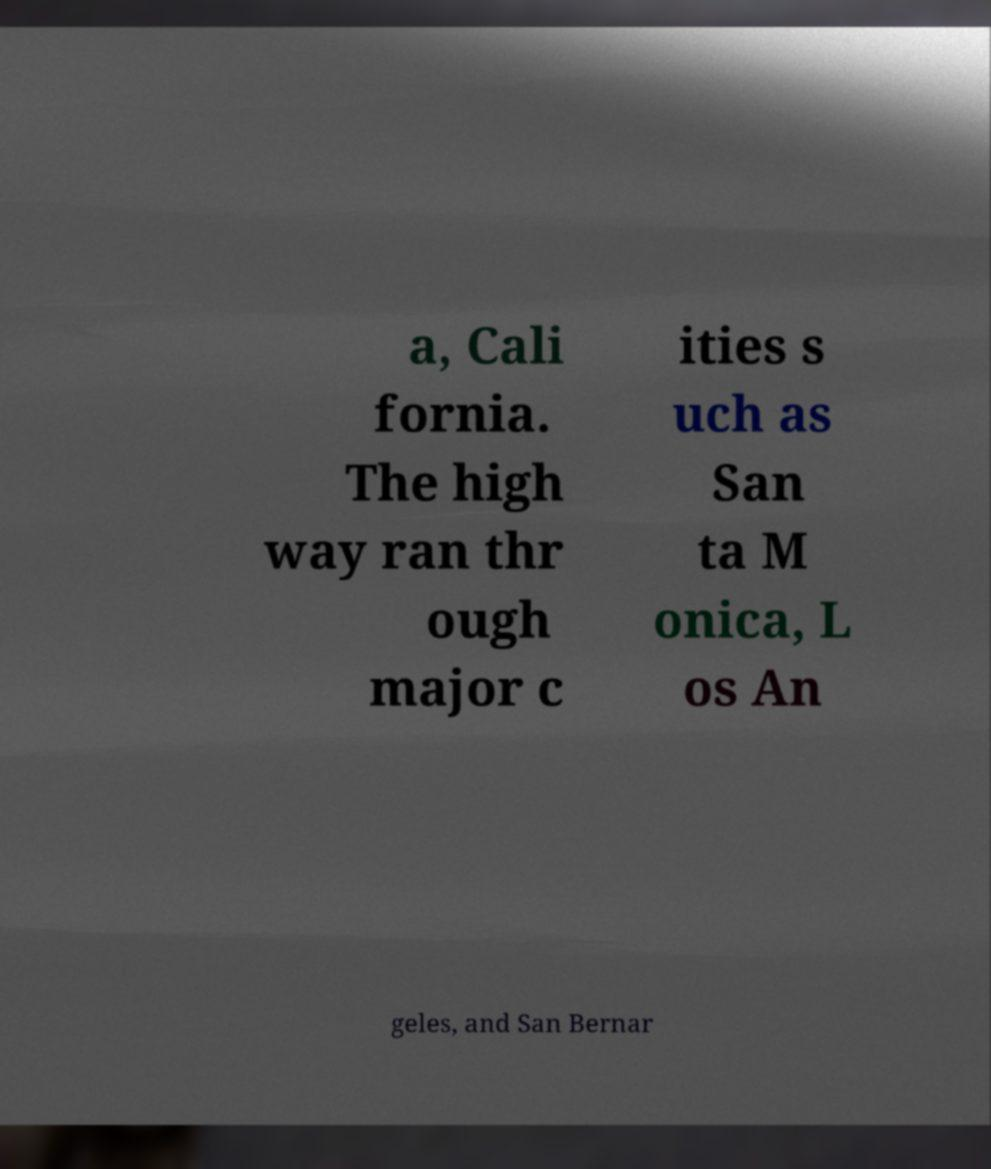Could you extract and type out the text from this image? a, Cali fornia. The high way ran thr ough major c ities s uch as San ta M onica, L os An geles, and San Bernar 